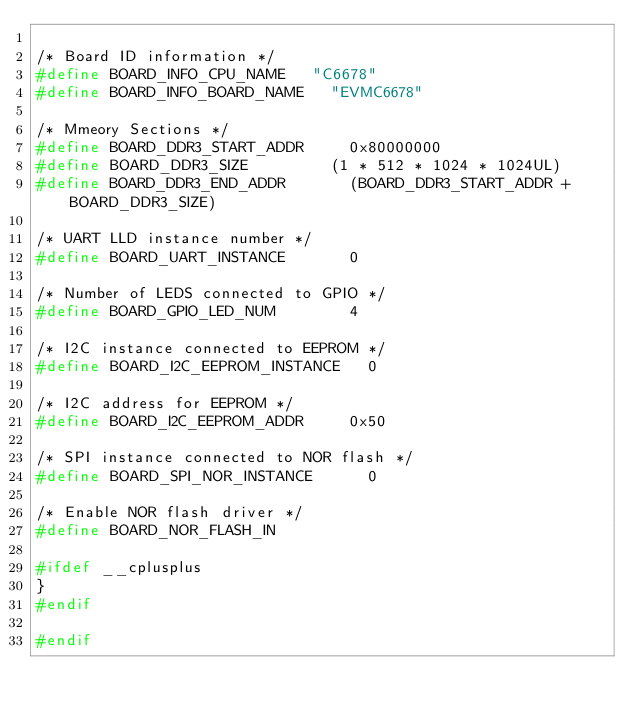Convert code to text. <code><loc_0><loc_0><loc_500><loc_500><_C_>
/* Board ID information */
#define BOARD_INFO_CPU_NAME 	"C6678"
#define BOARD_INFO_BOARD_NAME 	"EVMC6678"

/* Mmeory Sections */
#define BOARD_DDR3_START_ADDR			0x80000000
#define BOARD_DDR3_SIZE					(1 * 512 * 1024 * 1024UL)
#define BOARD_DDR3_END_ADDR				(BOARD_DDR3_START_ADDR + BOARD_DDR3_SIZE)

/* UART LLD instance number */
#define BOARD_UART_INSTANCE				0

/* Number of LEDS connected to GPIO */
#define BOARD_GPIO_LED_NUM				4

/* I2C instance connected to EEPROM */
#define BOARD_I2C_EEPROM_INSTANCE		0

/* I2C address for EEPROM */
#define BOARD_I2C_EEPROM_ADDR			0x50

/* SPI instance connected to NOR flash */
#define BOARD_SPI_NOR_INSTANCE			0

/* Enable NOR flash driver */
#define BOARD_NOR_FLASH_IN

#ifdef __cplusplus
}
#endif

#endif
</code> 